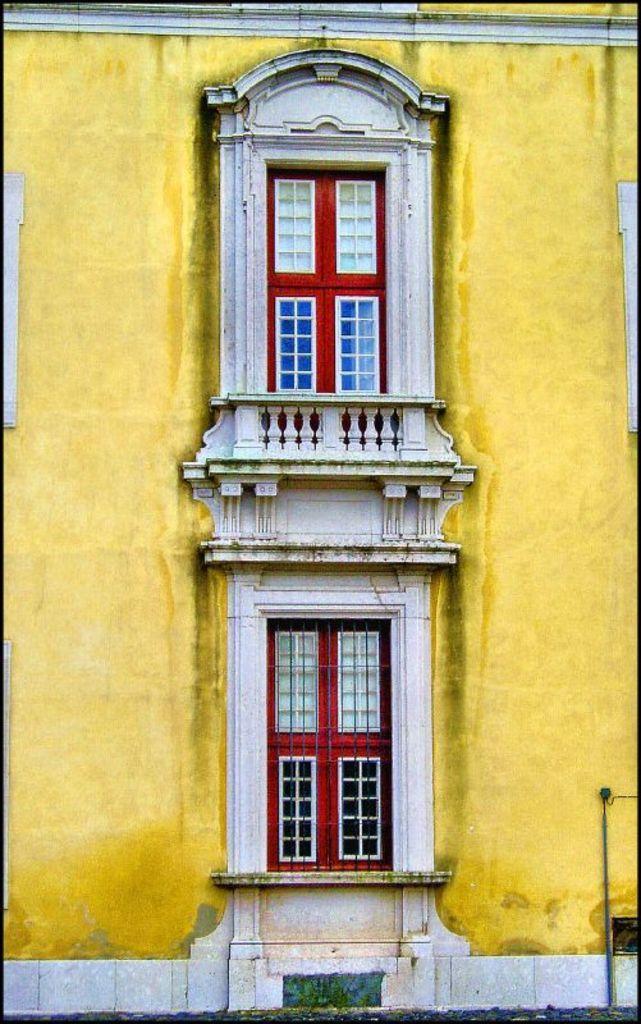Can you describe this image briefly? This picture shows a building wall and couple of windows. 